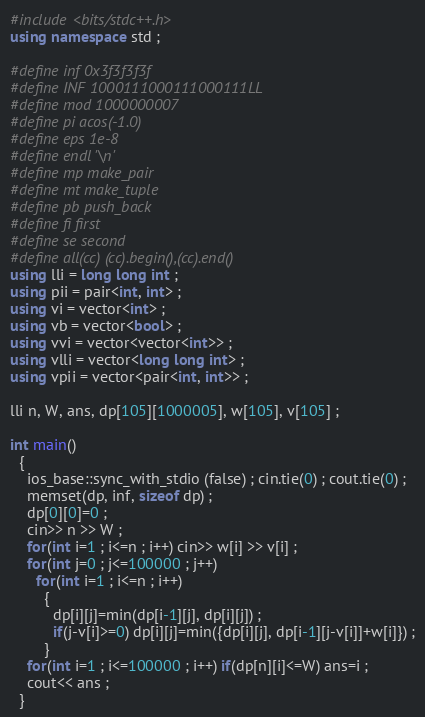Convert code to text. <code><loc_0><loc_0><loc_500><loc_500><_C++_>#include <bits/stdc++.h>
using namespace std ;

#define inf 0x3f3f3f3f
#define INF 1000111000111000111LL
#define mod 1000000007
#define pi acos(-1.0)
#define eps 1e-8
#define endl '\n'
#define mp make_pair
#define mt make_tuple
#define pb push_back
#define fi first
#define se second
#define all(cc) (cc).begin(),(cc).end()
using lli = long long int ;
using pii = pair<int, int> ;
using vi = vector<int> ;
using vb = vector<bool> ;
using vvi = vector<vector<int>> ;
using vlli = vector<long long int> ;
using vpii = vector<pair<int, int>> ;

lli n, W, ans, dp[105][1000005], w[105], v[105] ;

int main()
  {
    ios_base::sync_with_stdio (false) ; cin.tie(0) ; cout.tie(0) ;
    memset(dp, inf, sizeof dp) ;
    dp[0][0]=0 ;
    cin>> n >> W ;
    for(int i=1 ; i<=n ; i++) cin>> w[i] >> v[i] ;
    for(int j=0 ; j<=100000 ; j++)
      for(int i=1 ; i<=n ; i++)
        {
          dp[i][j]=min(dp[i-1][j], dp[i][j]) ;
          if(j-v[i]>=0) dp[i][j]=min({dp[i][j], dp[i-1][j-v[i]]+w[i]}) ;
        }
    for(int i=1 ; i<=100000 ; i++) if(dp[n][i]<=W) ans=i ;
    cout<< ans ;
  }
</code> 